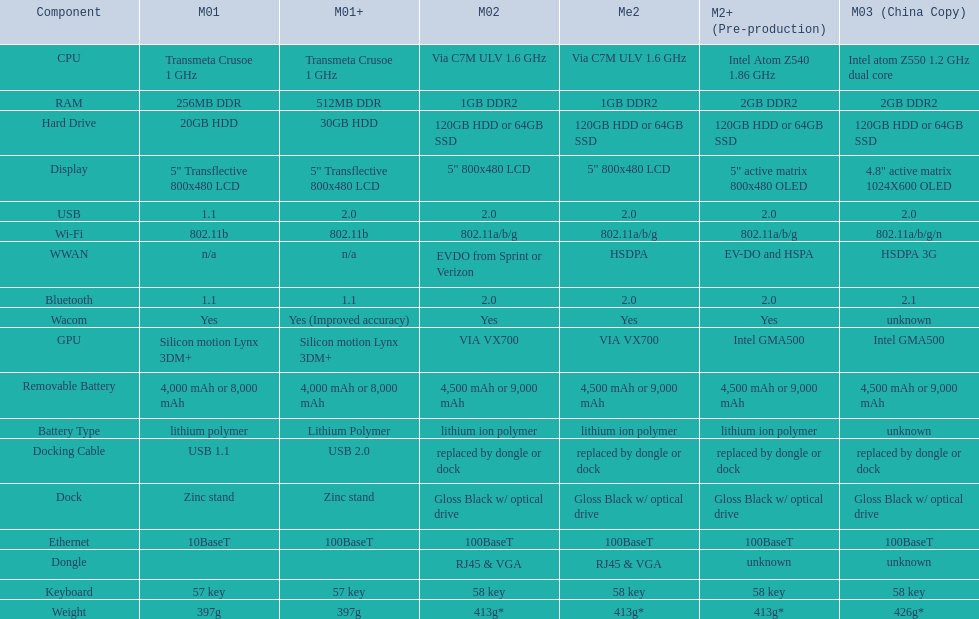How many models have 1.6ghz? 2. 